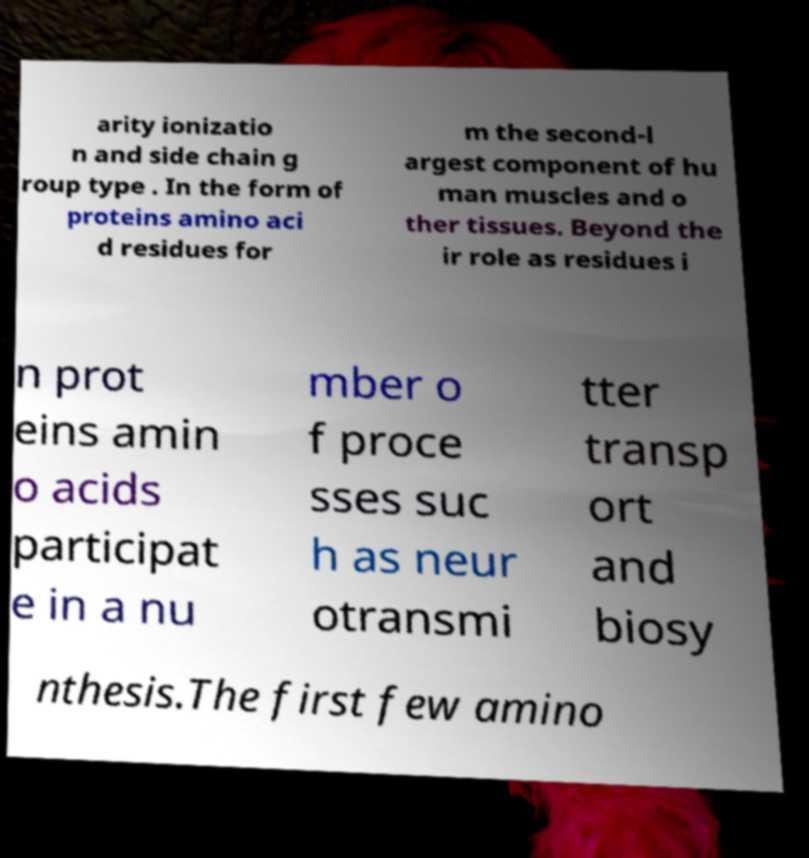Could you extract and type out the text from this image? arity ionizatio n and side chain g roup type . In the form of proteins amino aci d residues for m the second-l argest component of hu man muscles and o ther tissues. Beyond the ir role as residues i n prot eins amin o acids participat e in a nu mber o f proce sses suc h as neur otransmi tter transp ort and biosy nthesis.The first few amino 